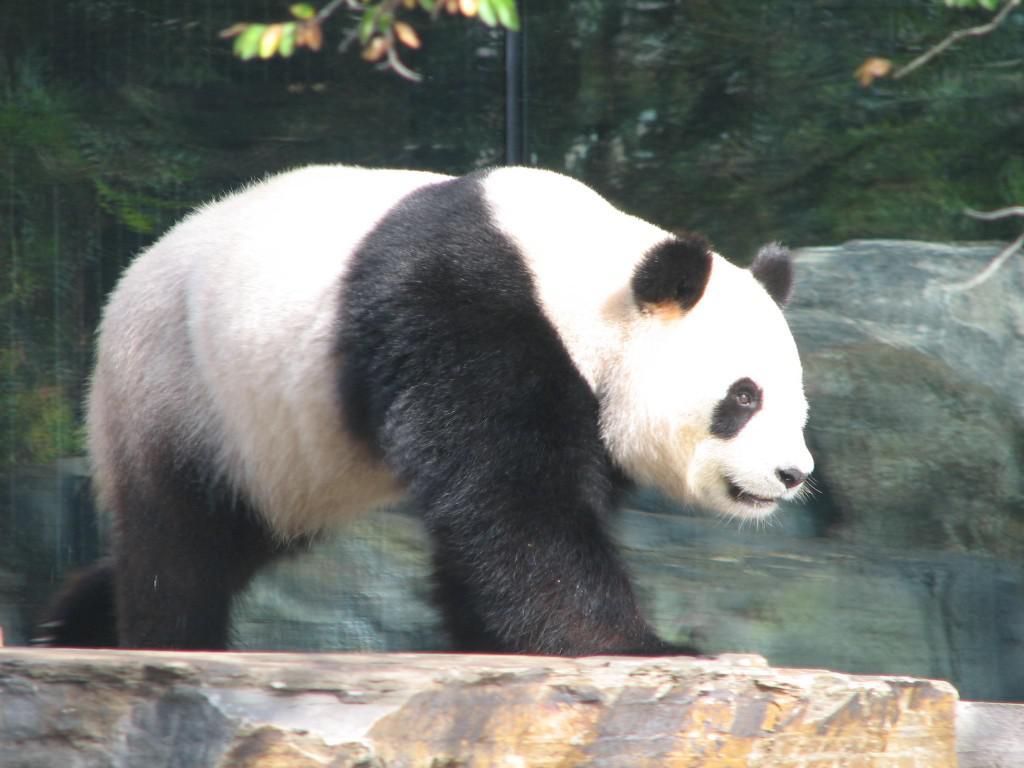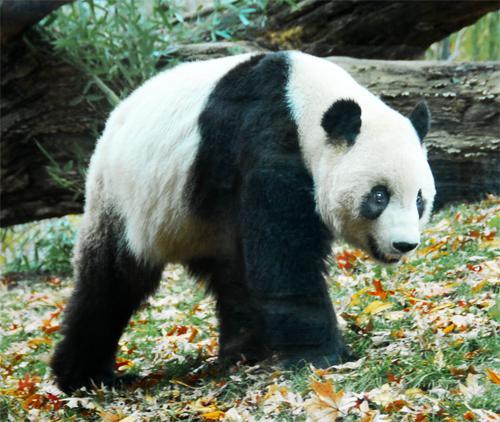The first image is the image on the left, the second image is the image on the right. Analyze the images presented: Is the assertion "All pandas are walking on all fours, and at least one panda is walking rightward with the camera-facing front paw forward." valid? Answer yes or no. Yes. The first image is the image on the left, the second image is the image on the right. Considering the images on both sides, is "In at least one image therei sa panda with a single black stripe on it's back walking in grass white facing forward right." valid? Answer yes or no. Yes. 